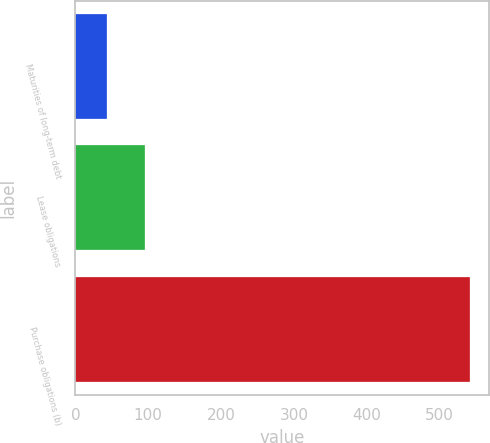Convert chart to OTSL. <chart><loc_0><loc_0><loc_500><loc_500><bar_chart><fcel>Maturities of long-term debt<fcel>Lease obligations<fcel>Purchase obligations (b)<nl><fcel>43<fcel>95<fcel>541<nl></chart> 